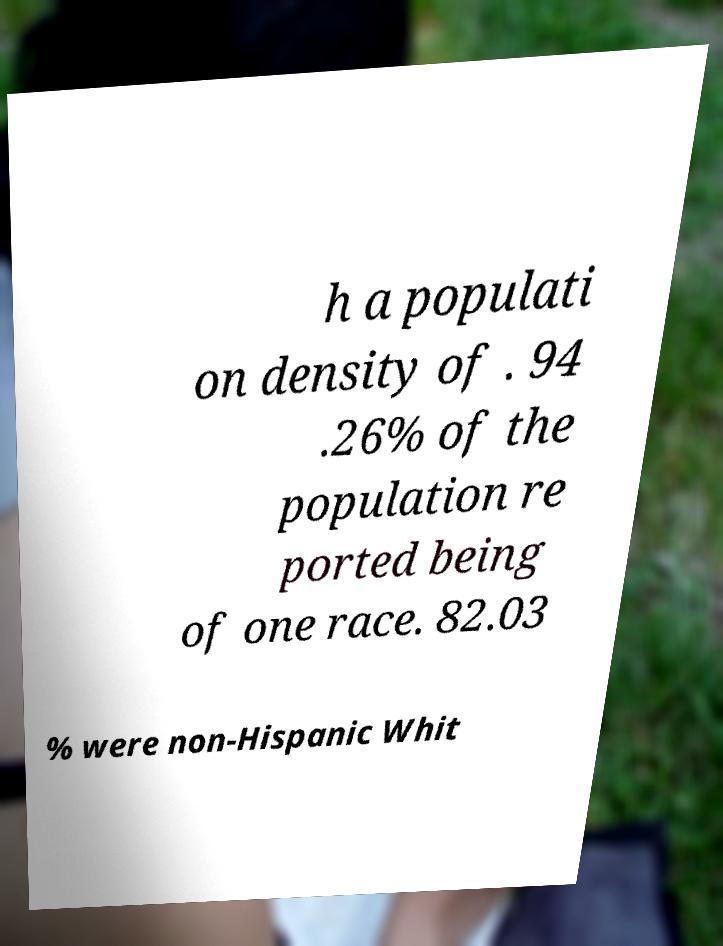Please identify and transcribe the text found in this image. h a populati on density of . 94 .26% of the population re ported being of one race. 82.03 % were non-Hispanic Whit 